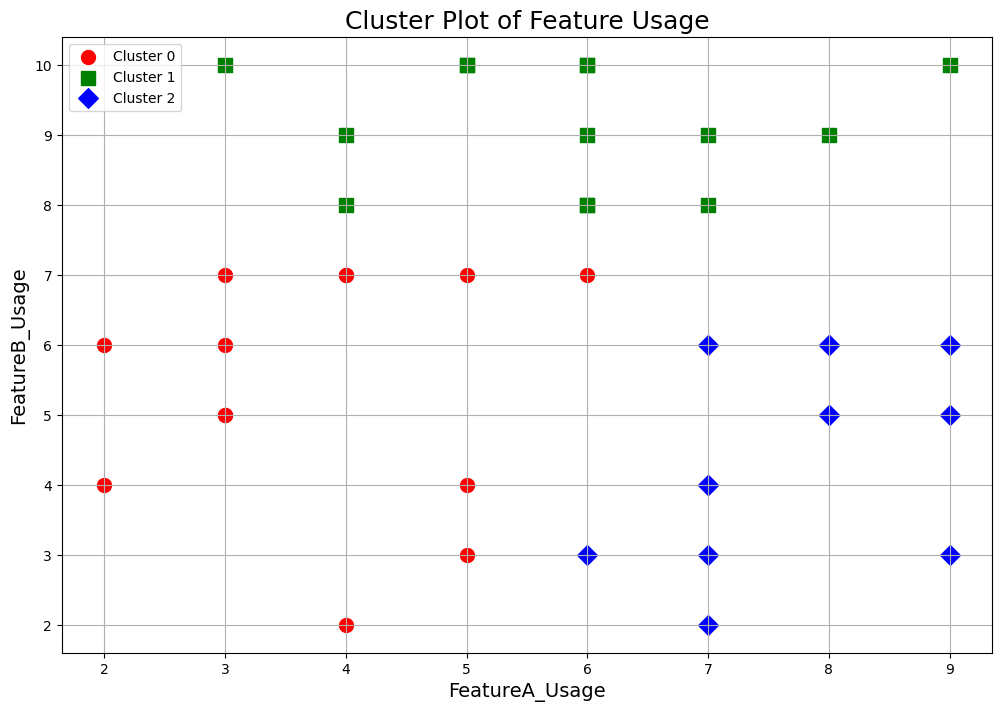How many clusters are represented in the plot? There are three markers and colors used in the plot, each representing a different cluster.
Answer: 3 Which cluster has the highest FeatureA_Usage? Identify the data points for each cluster based on their colors and then find the cluster that has the data points with the highest FeatureA_Usage values. The red cluster has the highest FeatureA_Usage values.
Answer: Red cluster Which cluster has the greatest spread in FeatureB_Usage? Observe the range of FeatureB_Usage values for each cluster. The cluster with the widest range of y-values in the plot has the greatest spread. The green cluster has the widest spread in FeatureB_Usage values.
Answer: Green cluster Compare the average FeatureA_Usage between the red and blue clusters? Calculate the x-axis positions for data points in the red and blue clusters. The red cluster tends to have higher FeatureA_Usage values compared to the blue cluster on average.
Answer: Red cluster higher Which cluster has the most balanced usage of FeatureA and FeatureB? Look for clusters where data points lie near the diagonal line from low (bottom left) to high (top right) values of FeatureA and FeatureB. The cluster with points more evenly distributed around this line would be the most balanced. The blue cluster appears most balanced in usage of FeatureA and FeatureB.
Answer: Blue cluster Are there any clusters where FeatureC_Usage is not considered? Since FeatureC_Usage is not plotted on the chart, assume that all clusters may equally consider FeatureC_Usage unless stated otherwise.
Answer: Not indicated Which demographic group primarily populates the red cluster? Review the clustering algorithm's details and data demographics to identify which features (excluding graphical details) match the demographic groups primarily populating the red cluster. Most likely, demographic data is not visually presented, so further data reference is needed.
Answer: Not discernible without additional data Which cluster has fewer outliers in FeatureB_Usage? Identify clusters with outliers by spotting data points much higher or lower than the core group of points around the center. The cluster with fewer points deviating significantly from the central trend has fewer outliers. The green cluster has fewer outliers in FeatureB_Usage.
Answer: Green cluster 